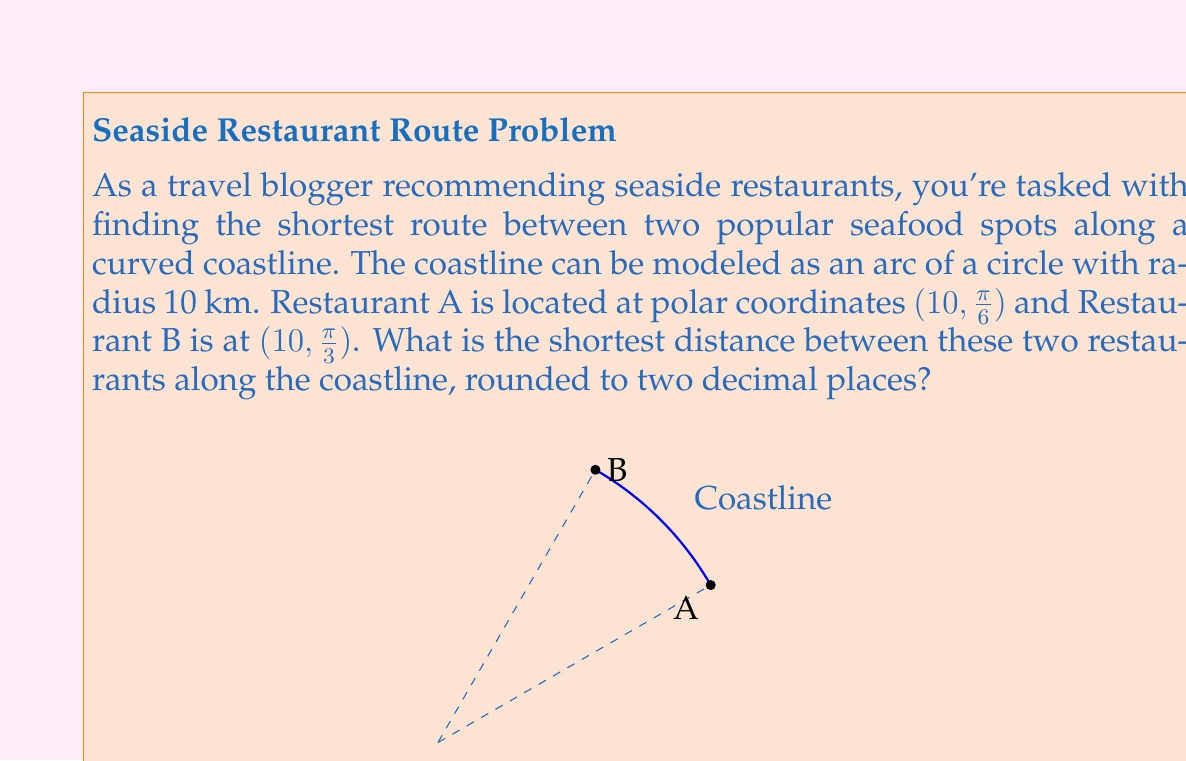Give your solution to this math problem. To solve this problem, we'll use the arc length formula in polar coordinates. Here's the step-by-step solution:

1) The general formula for arc length in polar coordinates is:

   $$s = r\theta$$

   where $s$ is the arc length, $r$ is the radius, and $\theta$ is the angle in radians.

2) We're given that the radius $r = 10$ km.

3) To find $\theta$, we need to calculate the difference between the angular coordinates of the two restaurants:

   $$\theta = \frac{\pi}{3} - \frac{\pi}{6} = \frac{\pi}{6}$$

4) Now we can substitute these values into our arc length formula:

   $$s = 10 \cdot \frac{\pi}{6}$$

5) Simplify:
   
   $$s = \frac{10\pi}{6} \approx 5.2359877559$$

6) Rounding to two decimal places:

   $$s \approx 5.24 \text{ km}$$

This represents the shortest distance between the two restaurants along the curved coastline.
Answer: $5.24$ km 